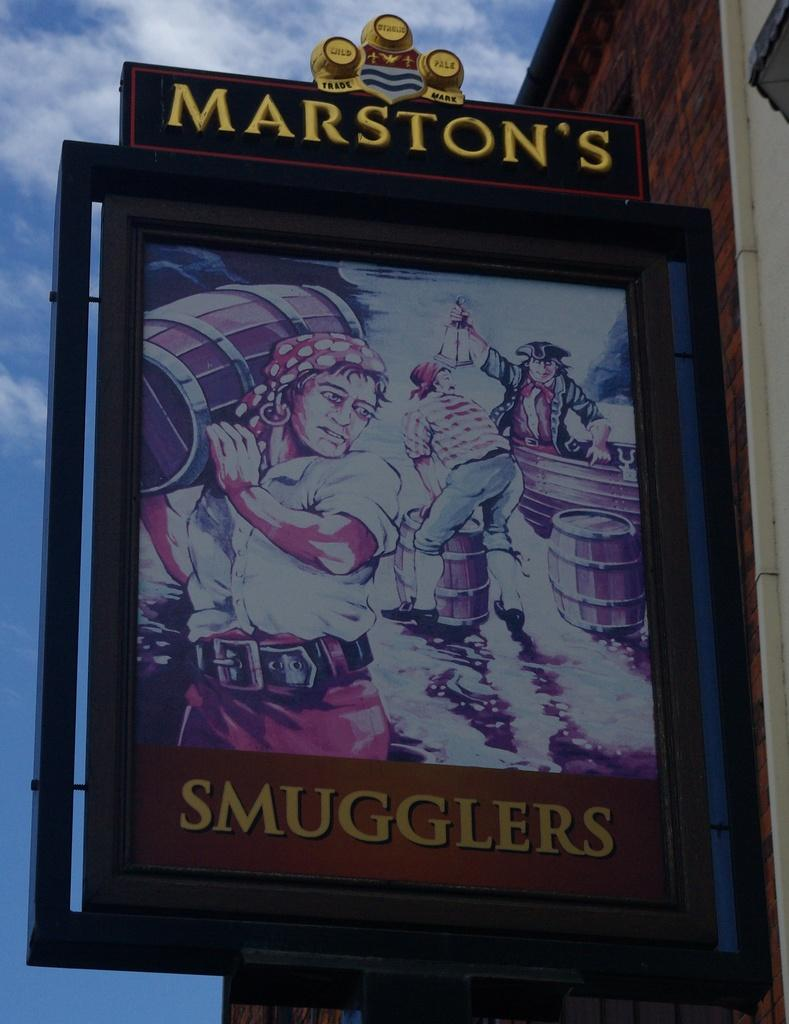<image>
Render a clear and concise summary of the photo. a poster that says 'marston's smugglers' on it 